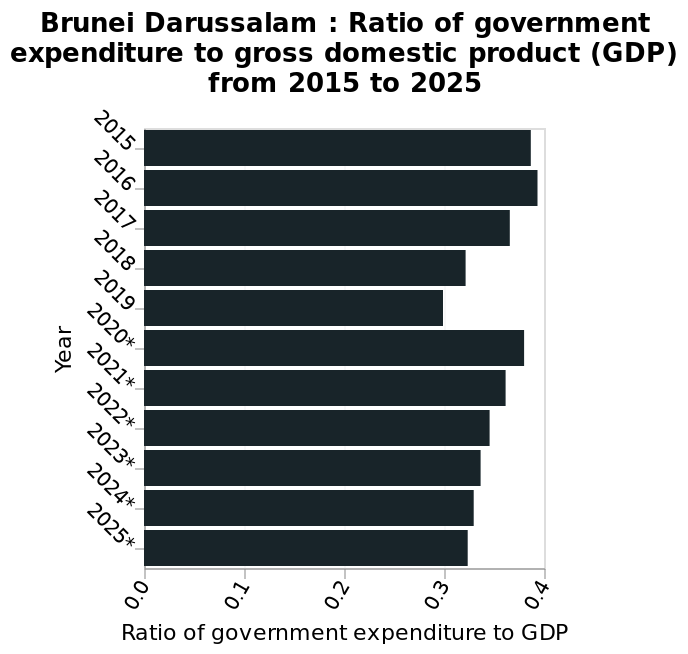<image>
What is the highest value on the y-axis in the bar chart? The highest value on the y-axis in the bar chart is 2025. What does the x-axis in the bar chart represent? The x-axis in the bar chart represents the ratio of government expenditure to gross domestic product (GDP). 